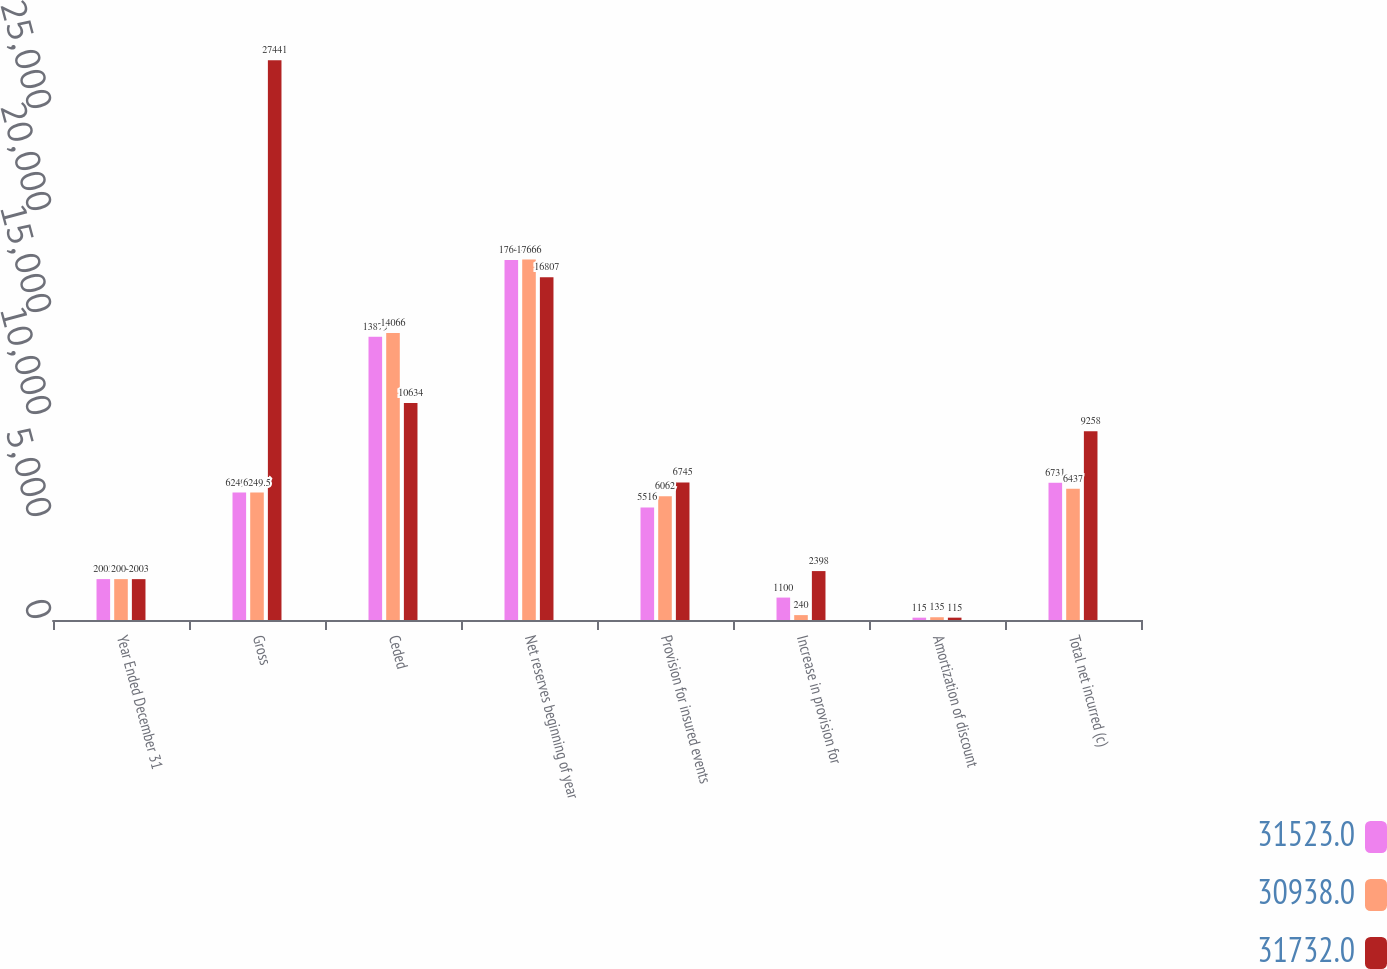<chart> <loc_0><loc_0><loc_500><loc_500><stacked_bar_chart><ecel><fcel>Year Ended December 31<fcel>Gross<fcel>Ceded<fcel>Net reserves beginning of year<fcel>Provision for insured events<fcel>Increase in provision for<fcel>Amortization of discount<fcel>Total net incurred (c)<nl><fcel>31523<fcel>2005<fcel>6249.5<fcel>13879<fcel>17644<fcel>5516<fcel>1100<fcel>115<fcel>6731<nl><fcel>30938<fcel>2004<fcel>6249.5<fcel>14066<fcel>17666<fcel>6062<fcel>240<fcel>135<fcel>6437<nl><fcel>31732<fcel>2003<fcel>27441<fcel>10634<fcel>16807<fcel>6745<fcel>2398<fcel>115<fcel>9258<nl></chart> 